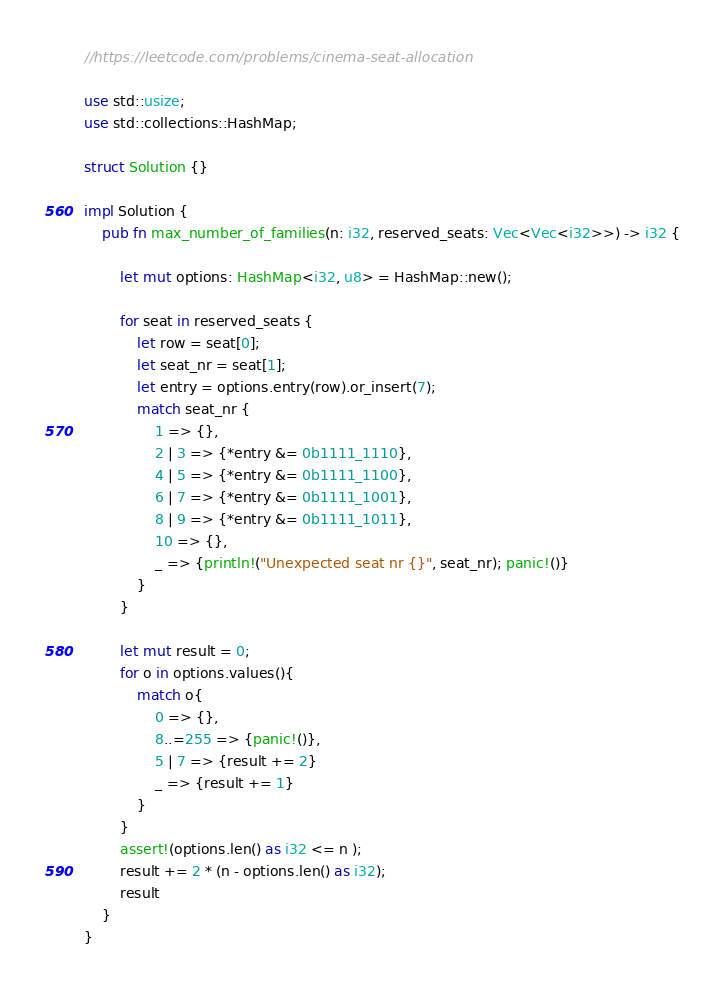Convert code to text. <code><loc_0><loc_0><loc_500><loc_500><_Rust_>//https://leetcode.com/problems/cinema-seat-allocation

use std::usize;
use std::collections::HashMap;

struct Solution {}

impl Solution {
    pub fn max_number_of_families(n: i32, reserved_seats: Vec<Vec<i32>>) -> i32 {

        let mut options: HashMap<i32, u8> = HashMap::new();

        for seat in reserved_seats {
            let row = seat[0];
            let seat_nr = seat[1];
            let entry = options.entry(row).or_insert(7);
            match seat_nr {
                1 => {},
                2 | 3 => {*entry &= 0b1111_1110},
                4 | 5 => {*entry &= 0b1111_1100},
                6 | 7 => {*entry &= 0b1111_1001},
                8 | 9 => {*entry &= 0b1111_1011},
                10 => {},
                _ => {println!("Unexpected seat nr {}", seat_nr); panic!()}
            }
        }

        let mut result = 0;
        for o in options.values(){
            match o{
                0 => {},
                8..=255 => {panic!()},
                5 | 7 => {result += 2}
                _ => {result += 1}
            }
        }
        assert!(options.len() as i32 <= n );
        result += 2 * (n - options.len() as i32);
        result
    }
}
</code> 